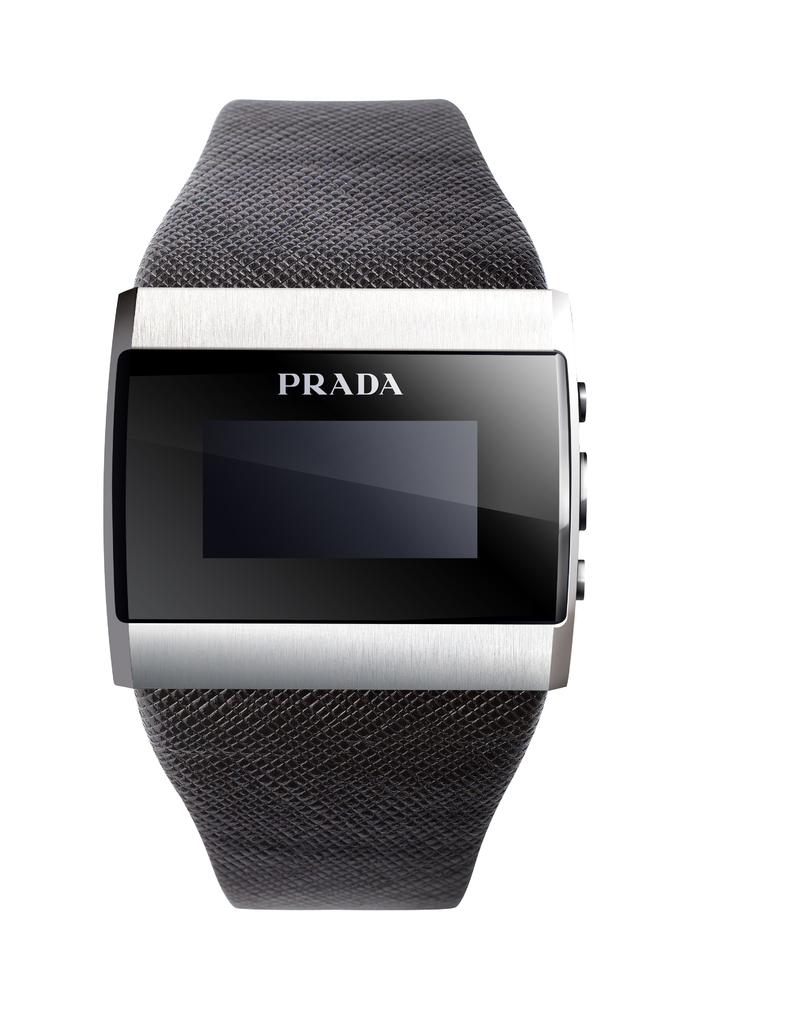<image>
Offer a succinct explanation of the picture presented. Black and silver Prada watch with a square screen. 